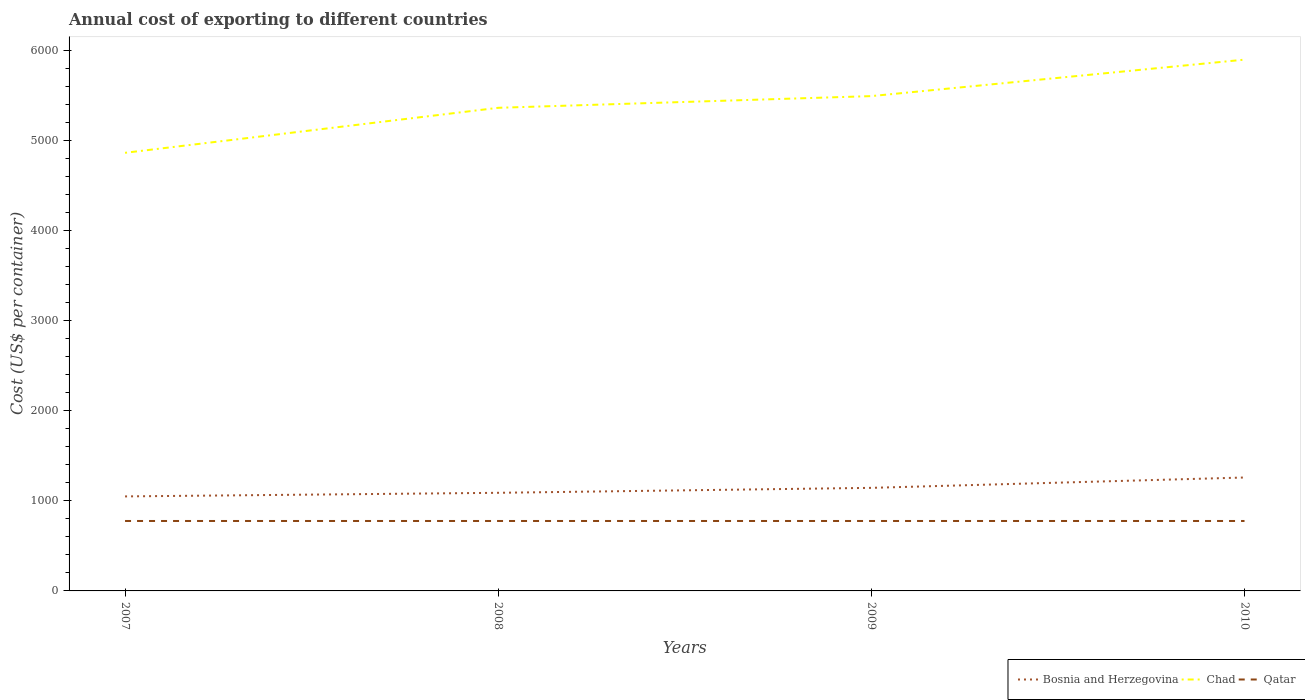Is the number of lines equal to the number of legend labels?
Your answer should be compact. Yes. Across all years, what is the maximum total annual cost of exporting in Chad?
Provide a succinct answer. 4867. In which year was the total annual cost of exporting in Qatar maximum?
Make the answer very short. 2007. What is the total total annual cost of exporting in Qatar in the graph?
Offer a terse response. 0. How many years are there in the graph?
Offer a terse response. 4. What is the difference between two consecutive major ticks on the Y-axis?
Give a very brief answer. 1000. Are the values on the major ticks of Y-axis written in scientific E-notation?
Make the answer very short. No. Does the graph contain any zero values?
Your answer should be compact. No. Does the graph contain grids?
Your answer should be compact. No. Where does the legend appear in the graph?
Your response must be concise. Bottom right. How many legend labels are there?
Give a very brief answer. 3. What is the title of the graph?
Provide a short and direct response. Annual cost of exporting to different countries. What is the label or title of the X-axis?
Ensure brevity in your answer.  Years. What is the label or title of the Y-axis?
Make the answer very short. Cost (US$ per container). What is the Cost (US$ per container) in Bosnia and Herzegovina in 2007?
Keep it short and to the point. 1050. What is the Cost (US$ per container) of Chad in 2007?
Your answer should be compact. 4867. What is the Cost (US$ per container) of Qatar in 2007?
Your answer should be very brief. 777. What is the Cost (US$ per container) of Bosnia and Herzegovina in 2008?
Keep it short and to the point. 1090. What is the Cost (US$ per container) in Chad in 2008?
Give a very brief answer. 5367. What is the Cost (US$ per container) of Qatar in 2008?
Provide a succinct answer. 777. What is the Cost (US$ per container) in Bosnia and Herzegovina in 2009?
Your answer should be very brief. 1145. What is the Cost (US$ per container) in Chad in 2009?
Keep it short and to the point. 5497. What is the Cost (US$ per container) in Qatar in 2009?
Offer a very short reply. 777. What is the Cost (US$ per container) of Bosnia and Herzegovina in 2010?
Offer a terse response. 1260. What is the Cost (US$ per container) in Chad in 2010?
Your response must be concise. 5902. What is the Cost (US$ per container) in Qatar in 2010?
Offer a terse response. 777. Across all years, what is the maximum Cost (US$ per container) in Bosnia and Herzegovina?
Provide a succinct answer. 1260. Across all years, what is the maximum Cost (US$ per container) of Chad?
Offer a very short reply. 5902. Across all years, what is the maximum Cost (US$ per container) of Qatar?
Offer a very short reply. 777. Across all years, what is the minimum Cost (US$ per container) in Bosnia and Herzegovina?
Provide a short and direct response. 1050. Across all years, what is the minimum Cost (US$ per container) of Chad?
Provide a short and direct response. 4867. Across all years, what is the minimum Cost (US$ per container) in Qatar?
Your answer should be very brief. 777. What is the total Cost (US$ per container) in Bosnia and Herzegovina in the graph?
Offer a terse response. 4545. What is the total Cost (US$ per container) in Chad in the graph?
Make the answer very short. 2.16e+04. What is the total Cost (US$ per container) of Qatar in the graph?
Give a very brief answer. 3108. What is the difference between the Cost (US$ per container) in Bosnia and Herzegovina in 2007 and that in 2008?
Your response must be concise. -40. What is the difference between the Cost (US$ per container) of Chad in 2007 and that in 2008?
Offer a very short reply. -500. What is the difference between the Cost (US$ per container) in Qatar in 2007 and that in 2008?
Provide a succinct answer. 0. What is the difference between the Cost (US$ per container) in Bosnia and Herzegovina in 2007 and that in 2009?
Give a very brief answer. -95. What is the difference between the Cost (US$ per container) of Chad in 2007 and that in 2009?
Ensure brevity in your answer.  -630. What is the difference between the Cost (US$ per container) in Qatar in 2007 and that in 2009?
Your answer should be compact. 0. What is the difference between the Cost (US$ per container) of Bosnia and Herzegovina in 2007 and that in 2010?
Give a very brief answer. -210. What is the difference between the Cost (US$ per container) of Chad in 2007 and that in 2010?
Ensure brevity in your answer.  -1035. What is the difference between the Cost (US$ per container) of Qatar in 2007 and that in 2010?
Your answer should be compact. 0. What is the difference between the Cost (US$ per container) of Bosnia and Herzegovina in 2008 and that in 2009?
Keep it short and to the point. -55. What is the difference between the Cost (US$ per container) in Chad in 2008 and that in 2009?
Make the answer very short. -130. What is the difference between the Cost (US$ per container) in Bosnia and Herzegovina in 2008 and that in 2010?
Your response must be concise. -170. What is the difference between the Cost (US$ per container) in Chad in 2008 and that in 2010?
Your answer should be compact. -535. What is the difference between the Cost (US$ per container) in Bosnia and Herzegovina in 2009 and that in 2010?
Your answer should be compact. -115. What is the difference between the Cost (US$ per container) of Chad in 2009 and that in 2010?
Give a very brief answer. -405. What is the difference between the Cost (US$ per container) in Bosnia and Herzegovina in 2007 and the Cost (US$ per container) in Chad in 2008?
Keep it short and to the point. -4317. What is the difference between the Cost (US$ per container) in Bosnia and Herzegovina in 2007 and the Cost (US$ per container) in Qatar in 2008?
Your response must be concise. 273. What is the difference between the Cost (US$ per container) in Chad in 2007 and the Cost (US$ per container) in Qatar in 2008?
Keep it short and to the point. 4090. What is the difference between the Cost (US$ per container) in Bosnia and Herzegovina in 2007 and the Cost (US$ per container) in Chad in 2009?
Give a very brief answer. -4447. What is the difference between the Cost (US$ per container) in Bosnia and Herzegovina in 2007 and the Cost (US$ per container) in Qatar in 2009?
Give a very brief answer. 273. What is the difference between the Cost (US$ per container) of Chad in 2007 and the Cost (US$ per container) of Qatar in 2009?
Give a very brief answer. 4090. What is the difference between the Cost (US$ per container) in Bosnia and Herzegovina in 2007 and the Cost (US$ per container) in Chad in 2010?
Give a very brief answer. -4852. What is the difference between the Cost (US$ per container) of Bosnia and Herzegovina in 2007 and the Cost (US$ per container) of Qatar in 2010?
Ensure brevity in your answer.  273. What is the difference between the Cost (US$ per container) of Chad in 2007 and the Cost (US$ per container) of Qatar in 2010?
Provide a succinct answer. 4090. What is the difference between the Cost (US$ per container) in Bosnia and Herzegovina in 2008 and the Cost (US$ per container) in Chad in 2009?
Keep it short and to the point. -4407. What is the difference between the Cost (US$ per container) of Bosnia and Herzegovina in 2008 and the Cost (US$ per container) of Qatar in 2009?
Make the answer very short. 313. What is the difference between the Cost (US$ per container) in Chad in 2008 and the Cost (US$ per container) in Qatar in 2009?
Provide a succinct answer. 4590. What is the difference between the Cost (US$ per container) of Bosnia and Herzegovina in 2008 and the Cost (US$ per container) of Chad in 2010?
Provide a succinct answer. -4812. What is the difference between the Cost (US$ per container) of Bosnia and Herzegovina in 2008 and the Cost (US$ per container) of Qatar in 2010?
Give a very brief answer. 313. What is the difference between the Cost (US$ per container) in Chad in 2008 and the Cost (US$ per container) in Qatar in 2010?
Your answer should be very brief. 4590. What is the difference between the Cost (US$ per container) in Bosnia and Herzegovina in 2009 and the Cost (US$ per container) in Chad in 2010?
Your answer should be very brief. -4757. What is the difference between the Cost (US$ per container) of Bosnia and Herzegovina in 2009 and the Cost (US$ per container) of Qatar in 2010?
Your answer should be very brief. 368. What is the difference between the Cost (US$ per container) of Chad in 2009 and the Cost (US$ per container) of Qatar in 2010?
Your response must be concise. 4720. What is the average Cost (US$ per container) in Bosnia and Herzegovina per year?
Offer a very short reply. 1136.25. What is the average Cost (US$ per container) of Chad per year?
Offer a terse response. 5408.25. What is the average Cost (US$ per container) in Qatar per year?
Keep it short and to the point. 777. In the year 2007, what is the difference between the Cost (US$ per container) of Bosnia and Herzegovina and Cost (US$ per container) of Chad?
Provide a succinct answer. -3817. In the year 2007, what is the difference between the Cost (US$ per container) in Bosnia and Herzegovina and Cost (US$ per container) in Qatar?
Give a very brief answer. 273. In the year 2007, what is the difference between the Cost (US$ per container) in Chad and Cost (US$ per container) in Qatar?
Ensure brevity in your answer.  4090. In the year 2008, what is the difference between the Cost (US$ per container) in Bosnia and Herzegovina and Cost (US$ per container) in Chad?
Give a very brief answer. -4277. In the year 2008, what is the difference between the Cost (US$ per container) in Bosnia and Herzegovina and Cost (US$ per container) in Qatar?
Your response must be concise. 313. In the year 2008, what is the difference between the Cost (US$ per container) in Chad and Cost (US$ per container) in Qatar?
Offer a very short reply. 4590. In the year 2009, what is the difference between the Cost (US$ per container) of Bosnia and Herzegovina and Cost (US$ per container) of Chad?
Provide a succinct answer. -4352. In the year 2009, what is the difference between the Cost (US$ per container) of Bosnia and Herzegovina and Cost (US$ per container) of Qatar?
Your answer should be very brief. 368. In the year 2009, what is the difference between the Cost (US$ per container) in Chad and Cost (US$ per container) in Qatar?
Keep it short and to the point. 4720. In the year 2010, what is the difference between the Cost (US$ per container) of Bosnia and Herzegovina and Cost (US$ per container) of Chad?
Provide a succinct answer. -4642. In the year 2010, what is the difference between the Cost (US$ per container) in Bosnia and Herzegovina and Cost (US$ per container) in Qatar?
Provide a succinct answer. 483. In the year 2010, what is the difference between the Cost (US$ per container) of Chad and Cost (US$ per container) of Qatar?
Your response must be concise. 5125. What is the ratio of the Cost (US$ per container) in Bosnia and Herzegovina in 2007 to that in 2008?
Your answer should be very brief. 0.96. What is the ratio of the Cost (US$ per container) of Chad in 2007 to that in 2008?
Ensure brevity in your answer.  0.91. What is the ratio of the Cost (US$ per container) in Qatar in 2007 to that in 2008?
Ensure brevity in your answer.  1. What is the ratio of the Cost (US$ per container) of Bosnia and Herzegovina in 2007 to that in 2009?
Provide a short and direct response. 0.92. What is the ratio of the Cost (US$ per container) of Chad in 2007 to that in 2009?
Make the answer very short. 0.89. What is the ratio of the Cost (US$ per container) of Chad in 2007 to that in 2010?
Your answer should be very brief. 0.82. What is the ratio of the Cost (US$ per container) in Qatar in 2007 to that in 2010?
Keep it short and to the point. 1. What is the ratio of the Cost (US$ per container) of Chad in 2008 to that in 2009?
Your answer should be very brief. 0.98. What is the ratio of the Cost (US$ per container) in Qatar in 2008 to that in 2009?
Make the answer very short. 1. What is the ratio of the Cost (US$ per container) in Bosnia and Herzegovina in 2008 to that in 2010?
Make the answer very short. 0.87. What is the ratio of the Cost (US$ per container) of Chad in 2008 to that in 2010?
Your response must be concise. 0.91. What is the ratio of the Cost (US$ per container) in Bosnia and Herzegovina in 2009 to that in 2010?
Provide a short and direct response. 0.91. What is the ratio of the Cost (US$ per container) in Chad in 2009 to that in 2010?
Provide a short and direct response. 0.93. What is the difference between the highest and the second highest Cost (US$ per container) of Bosnia and Herzegovina?
Ensure brevity in your answer.  115. What is the difference between the highest and the second highest Cost (US$ per container) of Chad?
Your answer should be very brief. 405. What is the difference between the highest and the second highest Cost (US$ per container) of Qatar?
Offer a very short reply. 0. What is the difference between the highest and the lowest Cost (US$ per container) in Bosnia and Herzegovina?
Ensure brevity in your answer.  210. What is the difference between the highest and the lowest Cost (US$ per container) of Chad?
Your response must be concise. 1035. What is the difference between the highest and the lowest Cost (US$ per container) in Qatar?
Offer a very short reply. 0. 